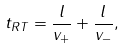<formula> <loc_0><loc_0><loc_500><loc_500>t _ { R T } = \frac { l } { v _ { + } } + \frac { l } { v _ { - } } ,</formula> 